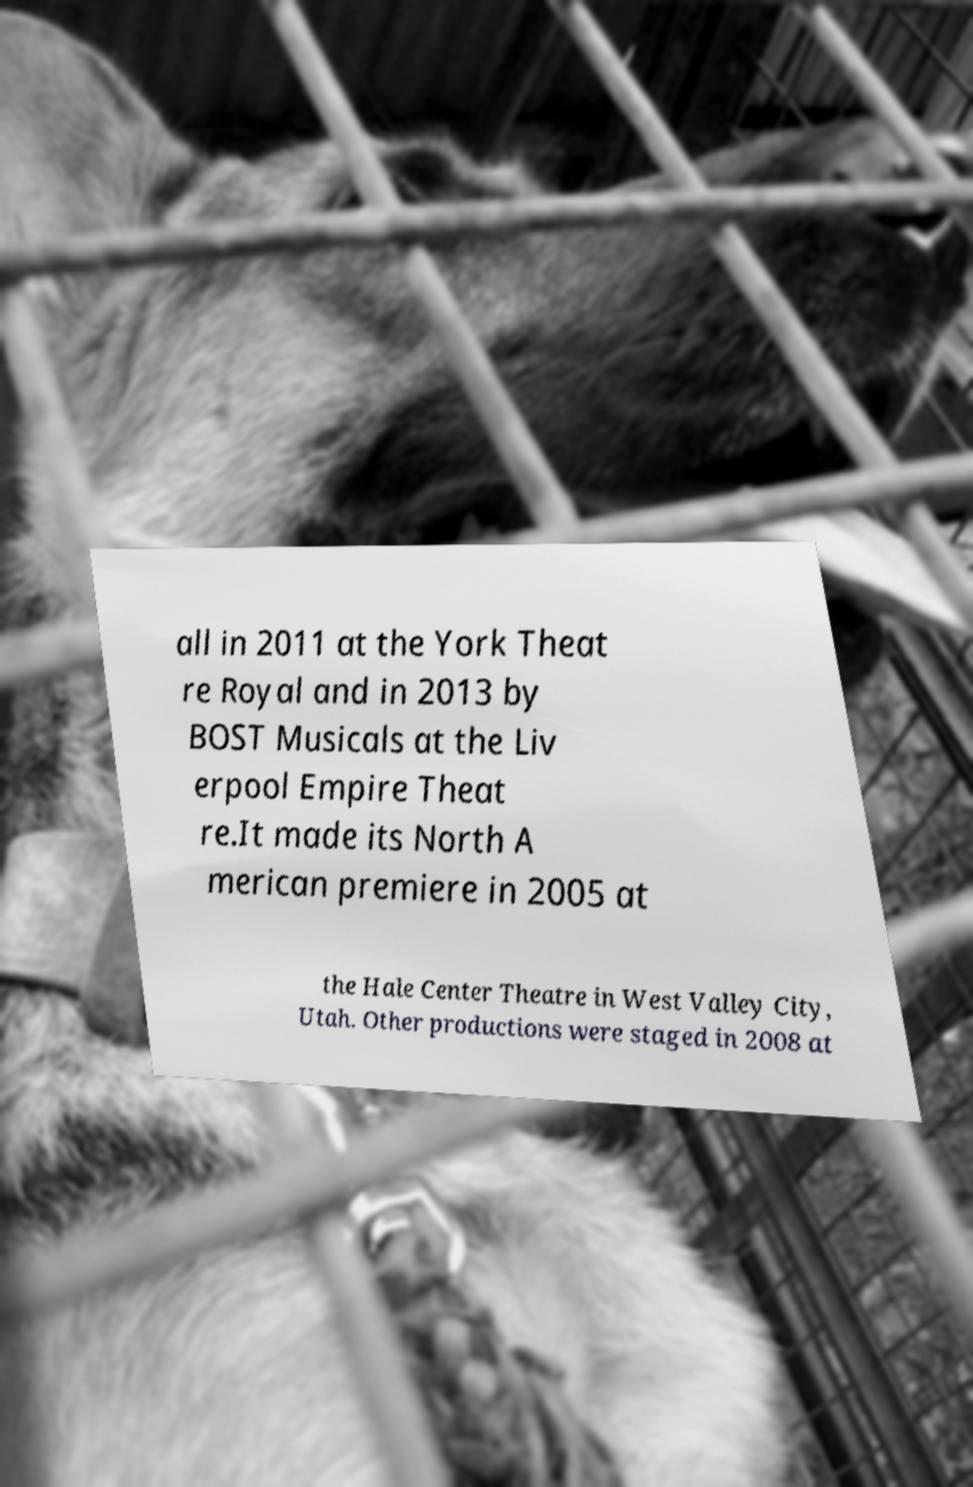What messages or text are displayed in this image? I need them in a readable, typed format. all in 2011 at the York Theat re Royal and in 2013 by BOST Musicals at the Liv erpool Empire Theat re.It made its North A merican premiere in 2005 at the Hale Center Theatre in West Valley City, Utah. Other productions were staged in 2008 at 